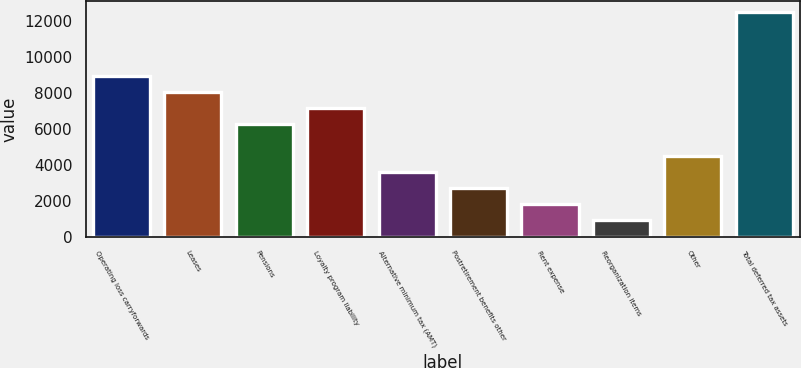Convert chart to OTSL. <chart><loc_0><loc_0><loc_500><loc_500><bar_chart><fcel>Operating loss carryforwards<fcel>Leases<fcel>Pensions<fcel>Loyalty program liability<fcel>Alternative minimum tax (AMT)<fcel>Postretirement benefits other<fcel>Rent expense<fcel>Reorganization items<fcel>Other<fcel>Total deferred tax assets<nl><fcel>8920<fcel>8029.9<fcel>6249.7<fcel>7139.8<fcel>3579.4<fcel>2689.3<fcel>1799.2<fcel>909.1<fcel>4469.5<fcel>12480.4<nl></chart> 